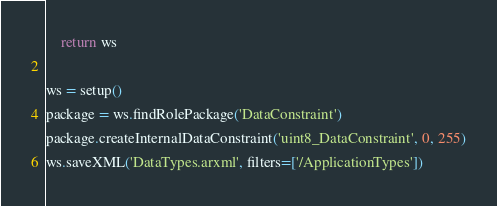<code> <loc_0><loc_0><loc_500><loc_500><_Python_>    return ws

ws = setup()
package = ws.findRolePackage('DataConstraint')
package.createInternalDataConstraint('uint8_DataConstraint', 0, 255)
ws.saveXML('DataTypes.arxml', filters=['/ApplicationTypes'])</code> 